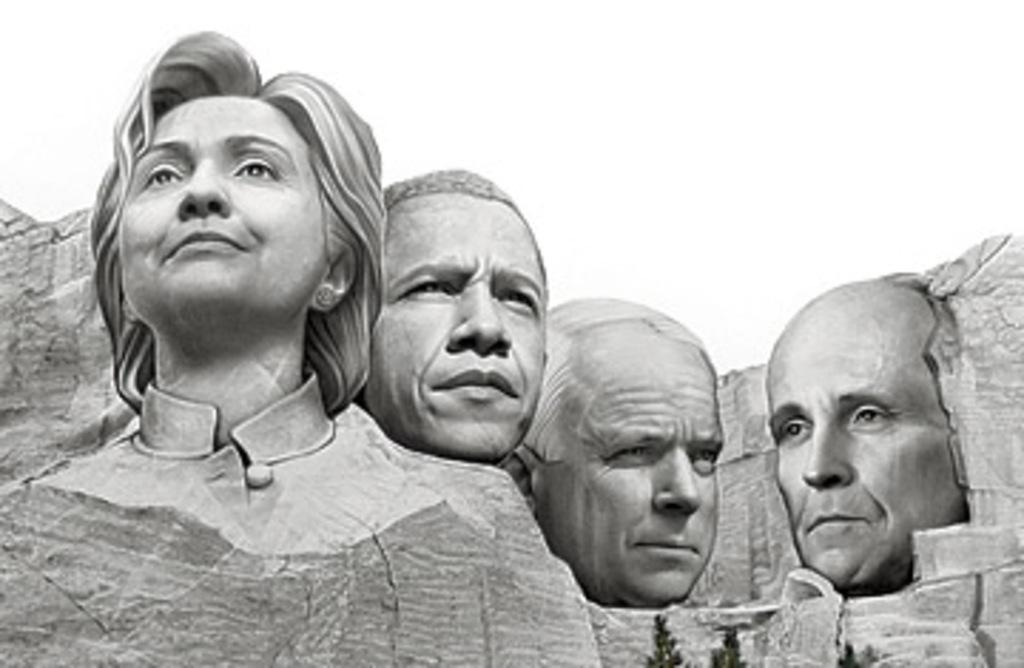What can be seen in the image? There are statues in the image. Where are the statues located? The statues are on a rock. Can you describe the statues in more detail? There is a statue of a lady and statues of three men. What type of butter is being used to clean the statues in the image? There is no butter present in the image, and the statues are not being cleaned. 